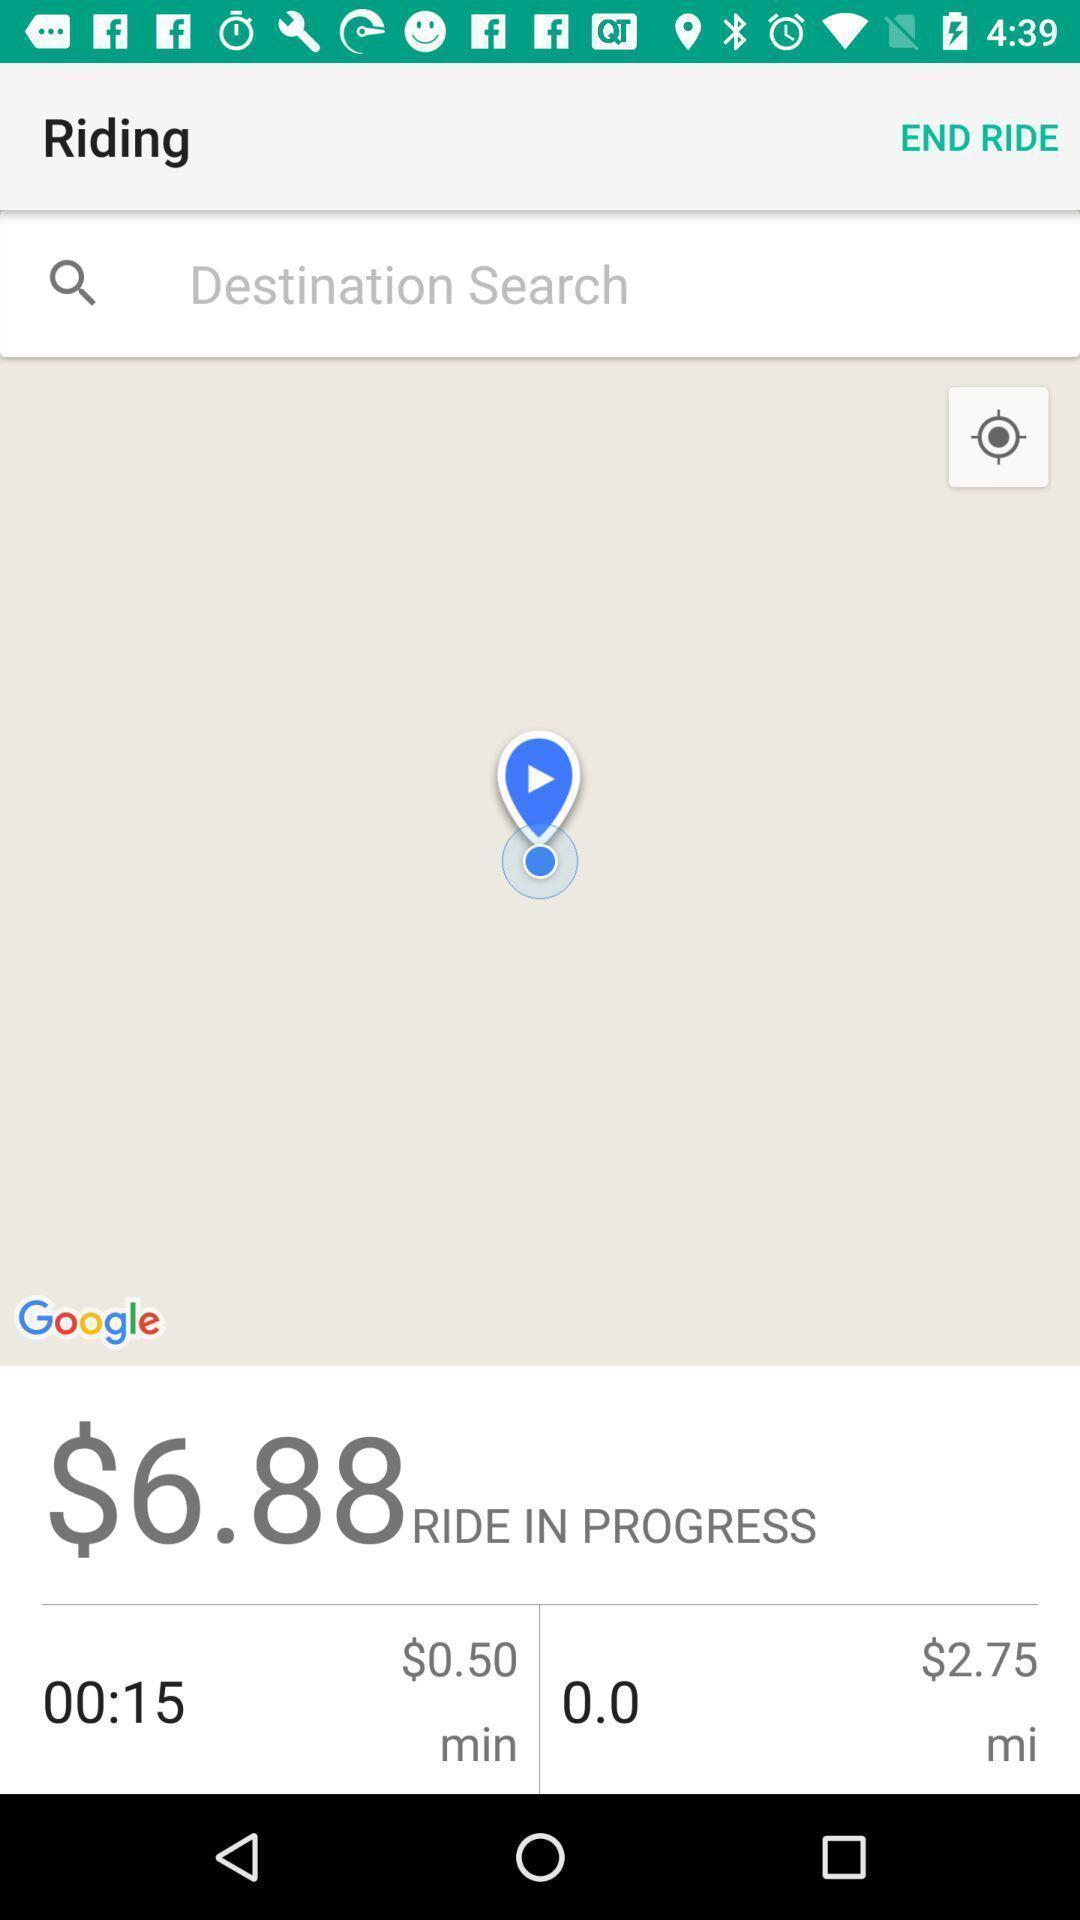Give me a narrative description of this picture. Screen shows about searched destination. 